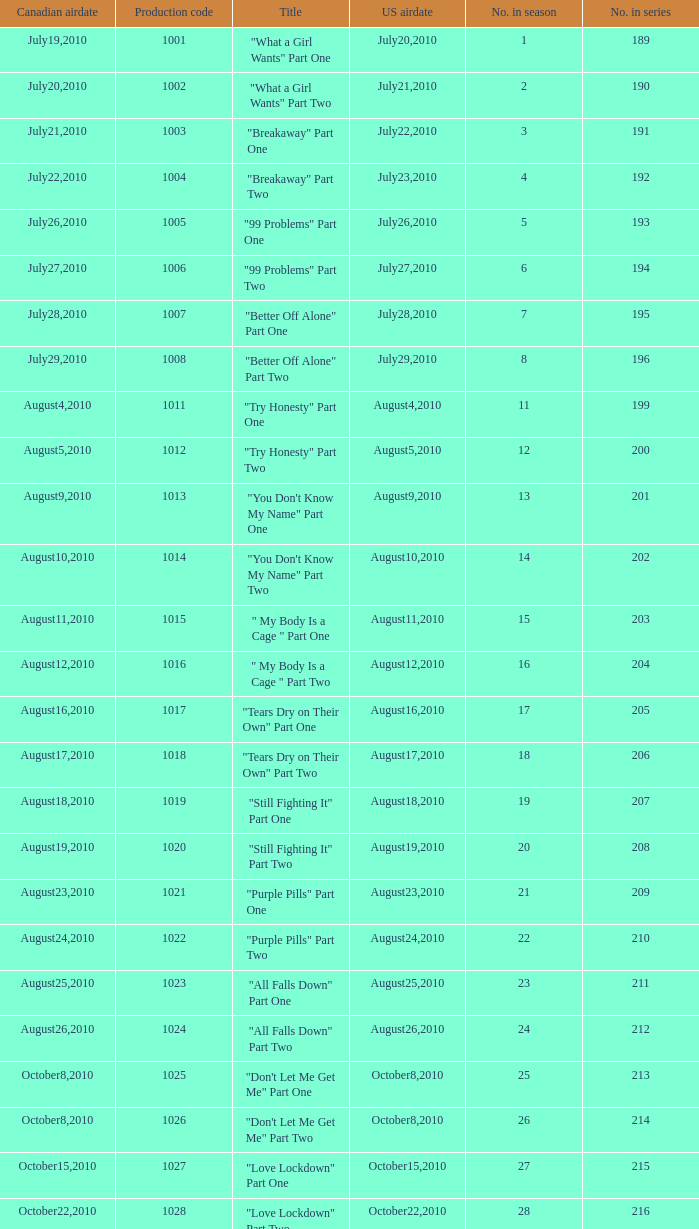What was the us airdate of "love lockdown" part one? October15,2010. 